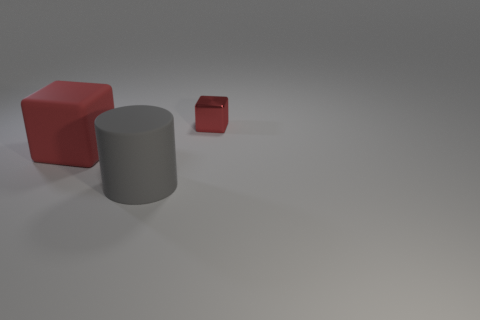Are there any other things that are made of the same material as the tiny red block?
Keep it short and to the point. No. How many other blocks have the same color as the tiny shiny cube?
Provide a succinct answer. 1. There is a block that is to the right of the large gray rubber cylinder on the right side of the big thing behind the big gray rubber object; how big is it?
Keep it short and to the point. Small. Is the tiny object the same shape as the large gray rubber object?
Your response must be concise. No. There is a thing that is to the right of the large red rubber object and behind the cylinder; what is its size?
Your answer should be very brief. Small. There is another small thing that is the same shape as the red matte object; what is its material?
Keep it short and to the point. Metal. There is a tiny block to the right of the block that is in front of the tiny red metallic block; what is it made of?
Ensure brevity in your answer.  Metal. There is a red metal thing; is its shape the same as the object that is left of the large gray matte cylinder?
Your answer should be compact. Yes. What number of matte objects are either tiny cubes or large gray things?
Ensure brevity in your answer.  1. What color is the large matte object that is to the left of the matte thing that is in front of the red object that is to the left of the small thing?
Make the answer very short. Red. 